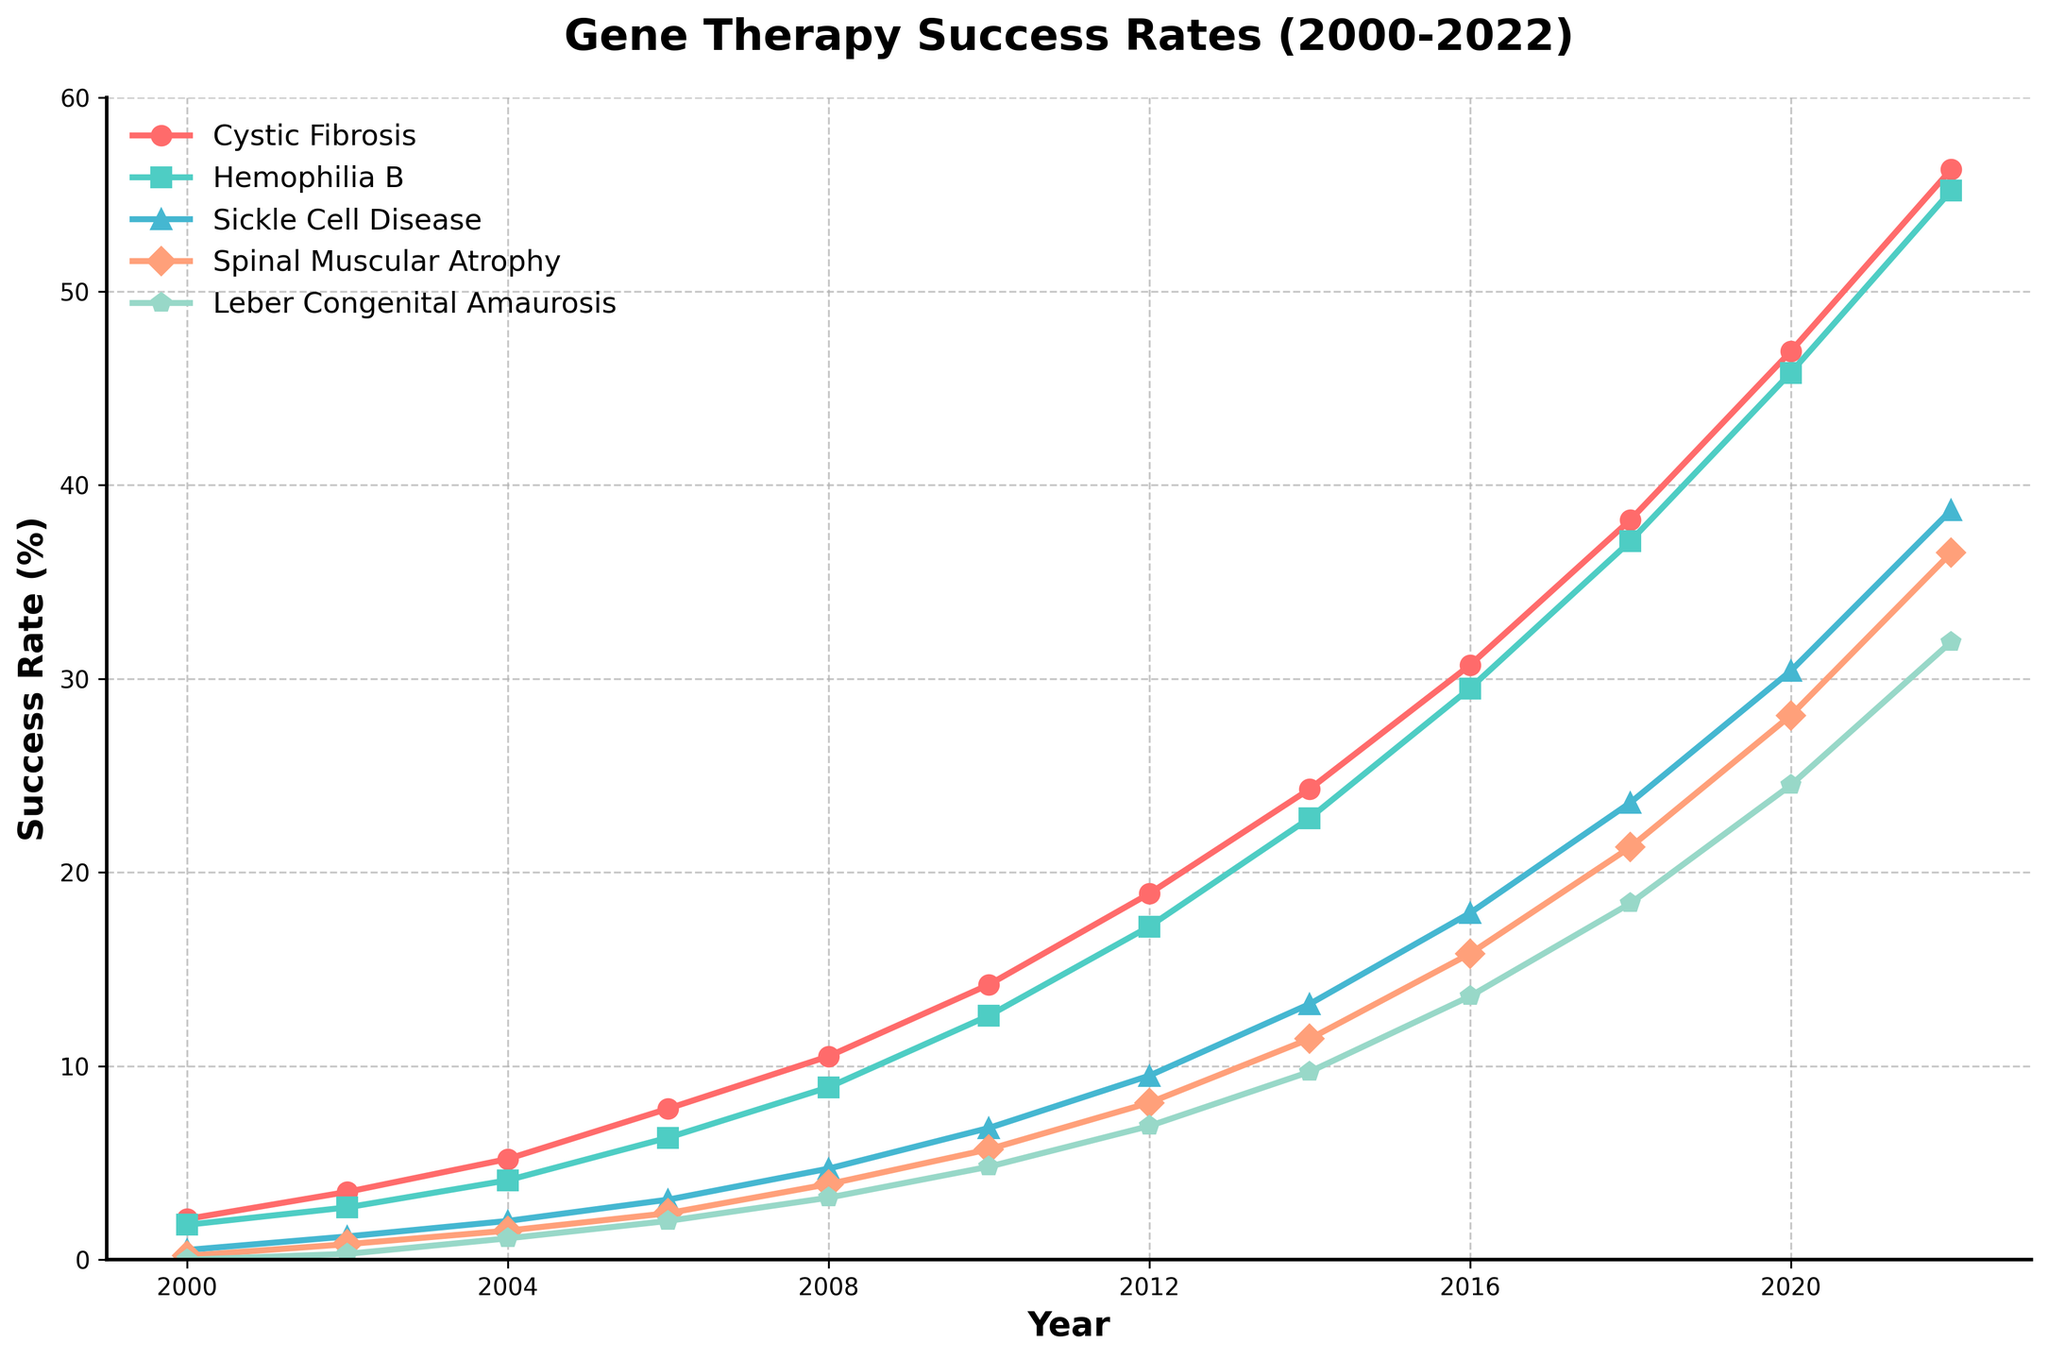What was the success rate for Cystic Fibrosis and Leber Congenital Amaurosis in 2008? Look at the points plotted for Cystic Fibrosis and Leber Congenital Amaurosis in the year 2008. The y-values represent the success rates. For Cystic Fibrosis, it is 10.5%, and for Leber Congenital Amaurosis, it is 3.2%.
Answer: Cystic Fibrosis: 10.5%, Leber Congenital Amaurosis: 3.2% Which genetic disorder had the highest success rate in 2018? Look at the data points in 2018 across all genetic disorders. The highest data point in this year corresponds to Cystic Fibrosis with a success rate of 38.2%.
Answer: Cystic Fibrosis Between Hemophilia B and Spinal Muscular Atrophy, which one showed a greater increase in success rate from 2000 to 2010? Calculate the increase for each disorder from 2000 to 2010. For Hemophilia B: 12.6% (2010) - 1.8% (2000) = 10.8%. For Spinal Muscular Atrophy: 5.7% (2010) - 0.2% (2000) = 5.5%. Hemophilia B showed a greater increase.
Answer: Hemophilia B What is the average success rate of Sickle Cell Disease from 2000 to 2022? Sum up the success rates for Sickle Cell Disease for all years and divide by the number of years. (0.5 + 1.2 + 2.0 + 3.1 + 4.7 + 6.8 + 9.5 + 13.2 + 17.9 + 23.6 + 30.4 + 38.7) / 12 = 12.4667
Answer: 12.5% Which disorder had the lowest success rate in 2022? Look at the data points for all disorders in 2022. The lowest success rate corresponds to Hemophilia B at 55.2%.
Answer: Hemophilia B Compare the success rates of Cystic Fibrosis in 2004 and 2014. By what percentage did it increase? Find the difference and then the percentage increase. (24.3% - 5.2%) / 5.2% * 100 = 367.3%
Answer: 367.3% In 2012, which disorder’s success rate was closest to 10%? Look at the success rates in 2012 and find the one closest to 10%. Spinal Muscular Atrophy has a success rate of 8.1%, which is closest.
Answer: Spinal Muscular Atrophy How many years did it take for Leber Congenital Amaurosis to achieve a success rate higher than 20%? Find the first year after 2000 where Leber Congenital Amaurosis success rate is above 20%. The first year is 2020. Thus, it took 2020-2000 = 20 years.
Answer: 20 years If you sum the success rates of all disorders in the year 2020, what is the total? Add the success rates for all disorders in 2020: 46.9 + 45.8 + 30.4 + 28.1 + 24.5 = 175.7
Answer: 175.7 Which disorder showed the greatest relative improvement from 2000 to 2022? Calculate the relative improvement for each disorder (2022 rate / 2000 rate). Compare these values: 
Cystic Fibrosis: 56.3 / 2.1 = 26.81 
Hemophilia B: 55.2 / 1.8 = 30.67 
Sickle Cell Disease: 38.7 / 0.5 = 77.4 
Spinal Muscular Atrophy: 36.5 /0.2 = 182.5 
Leber Congenital Amaurosis: 31.9 /0 = Undefined (as it starts from 0). 
The highest relative improvement is for Spinal Muscular Atrophy.
Answer: Spinal Muscular Atrophy 